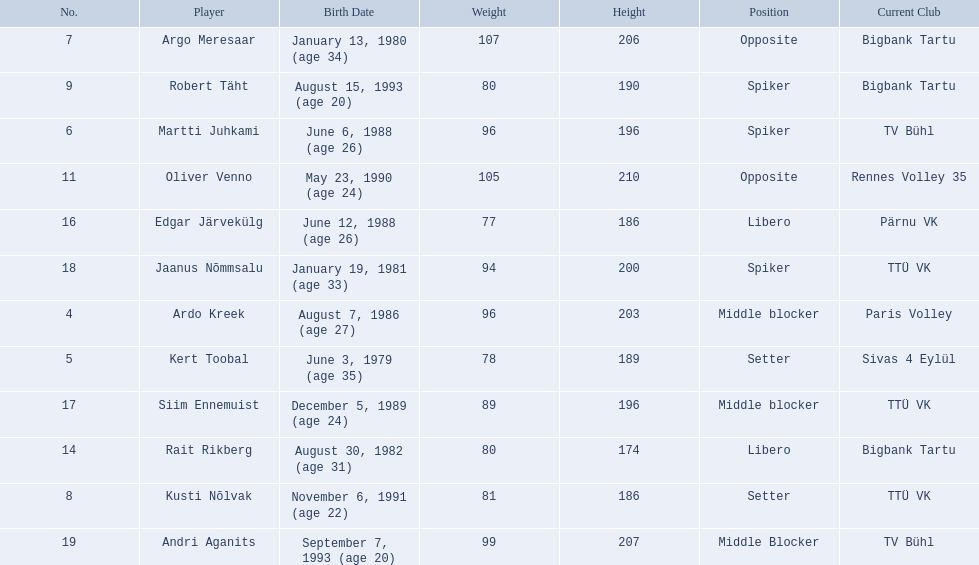What are the heights in cm of the men on the team? 203, 189, 196, 206, 186, 190, 210, 174, 186, 196, 200, 207. Could you parse the entire table as a dict? {'header': ['No.', 'Player', 'Birth Date', 'Weight', 'Height', 'Position', 'Current Club'], 'rows': [['7', 'Argo Meresaar', 'January 13, 1980 (age\xa034)', '107', '206', 'Opposite', 'Bigbank Tartu'], ['9', 'Robert Täht', 'August 15, 1993 (age\xa020)', '80', '190', 'Spiker', 'Bigbank Tartu'], ['6', 'Martti Juhkami', 'June 6, 1988 (age\xa026)', '96', '196', 'Spiker', 'TV Bühl'], ['11', 'Oliver Venno', 'May 23, 1990 (age\xa024)', '105', '210', 'Opposite', 'Rennes Volley 35'], ['16', 'Edgar Järvekülg', 'June 12, 1988 (age\xa026)', '77', '186', 'Libero', 'Pärnu VK'], ['18', 'Jaanus Nõmmsalu', 'January 19, 1981 (age\xa033)', '94', '200', 'Spiker', 'TTÜ VK'], ['4', 'Ardo Kreek', 'August 7, 1986 (age\xa027)', '96', '203', 'Middle blocker', 'Paris Volley'], ['5', 'Kert Toobal', 'June 3, 1979 (age\xa035)', '78', '189', 'Setter', 'Sivas 4 Eylül'], ['17', 'Siim Ennemuist', 'December 5, 1989 (age\xa024)', '89', '196', 'Middle blocker', 'TTÜ VK'], ['14', 'Rait Rikberg', 'August 30, 1982 (age\xa031)', '80', '174', 'Libero', 'Bigbank Tartu'], ['8', 'Kusti Nõlvak', 'November 6, 1991 (age\xa022)', '81', '186', 'Setter', 'TTÜ VK'], ['19', 'Andri Aganits', 'September 7, 1993 (age\xa020)', '99', '207', 'Middle Blocker', 'TV Bühl']]} What is the tallest height of a team member? 210. Which player stands at 210? Oliver Venno. 